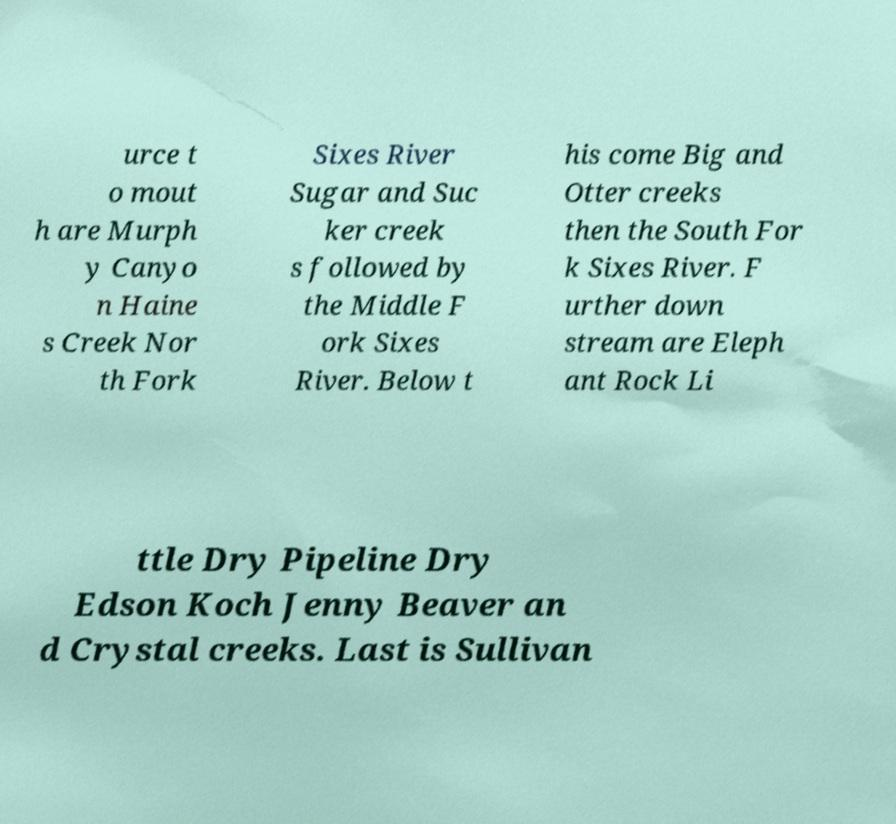For documentation purposes, I need the text within this image transcribed. Could you provide that? urce t o mout h are Murph y Canyo n Haine s Creek Nor th Fork Sixes River Sugar and Suc ker creek s followed by the Middle F ork Sixes River. Below t his come Big and Otter creeks then the South For k Sixes River. F urther down stream are Eleph ant Rock Li ttle Dry Pipeline Dry Edson Koch Jenny Beaver an d Crystal creeks. Last is Sullivan 